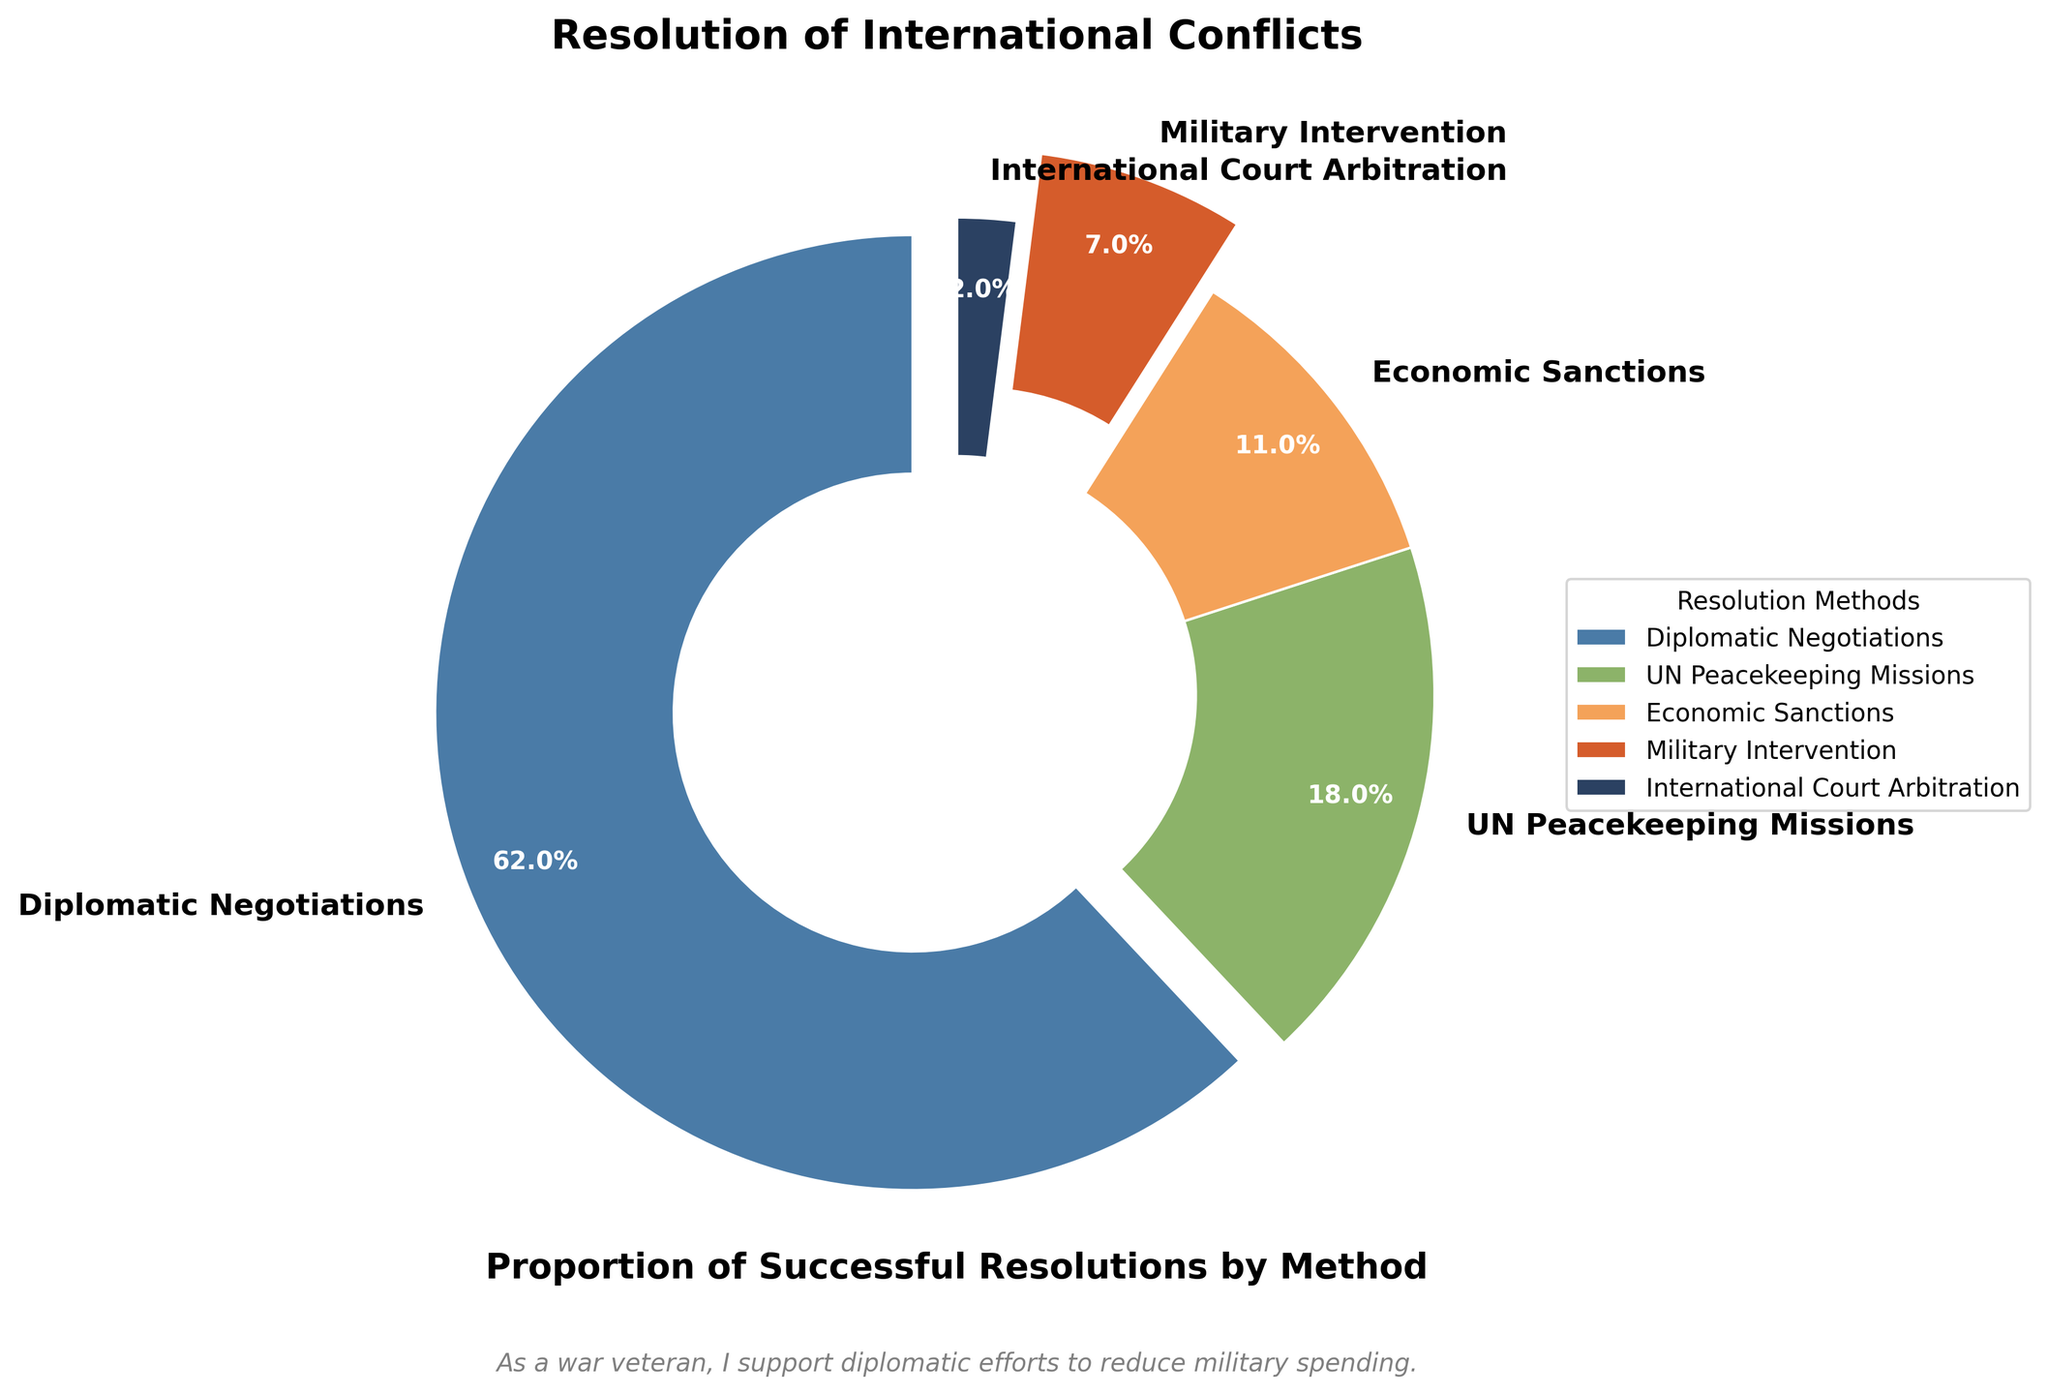What percentage of successful international conflicts were resolved through military intervention? We refer to the slice labeled "Military Intervention" and see a value of 7%.
Answer: 7% Which resolution method has the highest proportion of successful resolutions? We need to compare the percentages of all resolution methods and identify the highest one, which is "Diplomatic Negotiations" with 62%.
Answer: Diplomatic Negotiations How much more successful are diplomatic negotiations compared to military intervention? We find the percentage of Diplomatic Negotiations (62%) and Military Intervention (7%). Then, subtract the smaller value from the larger one: 62% - 7% = 55%.
Answer: 55% If you combine the proportions of UN Peacekeeping Missions and Economic Sanctions, does it surpass the proportion of Diplomatic Negotiations? We add the percentages of UN Peacekeeping Missions (18%) and Economic Sanctions (11%): 18% + 11% = 29%. We compare this sum with Diplomatic Negotiations (62%). Since 29% is less than 62%, the combined proportion does not surpass Diplomatic Negotiations.
Answer: No What is the combined proportion of successful resolutions achieved by non-military methods (excluding Military Intervention)? We sum the percentages for Diplomatic Negotiations (62%), UN Peacekeeping Missions (18%), Economic Sanctions (11%), and International Court Arbitration (2%): 62% + 18% + 11% + 2% = 93%.
Answer: 93% What resolution method has the smallest proportion in the pie chart? We locate the smallest percentage among the resolution methods, which is "International Court Arbitration" with 2%.
Answer: International Court Arbitration Are UN Peacekeeping Missions more successful than Economic Sanctions in resolving international conflicts? We compare the percentages of UN Peacekeeping Missions (18%) and Economic Sanctions (11%). Since 18% is greater than 11%, UN Peacekeeping Missions are more successful.
Answer: Yes What is the difference in the success rates between UN Peacekeeping Missions and Military Intervention? We find the percentages for UN Peacekeeping Missions (18%) and Military Intervention (7%). Then subtract the smaller value from the larger one: 18% - 7% = 11%.
Answer: 11% What color represents the proportion of successful resolutions achieved through Economic Sanctions? We refer to the pie chart, where the slice for Economic Sanctions is displayed in an orange color.
Answer: Orange 